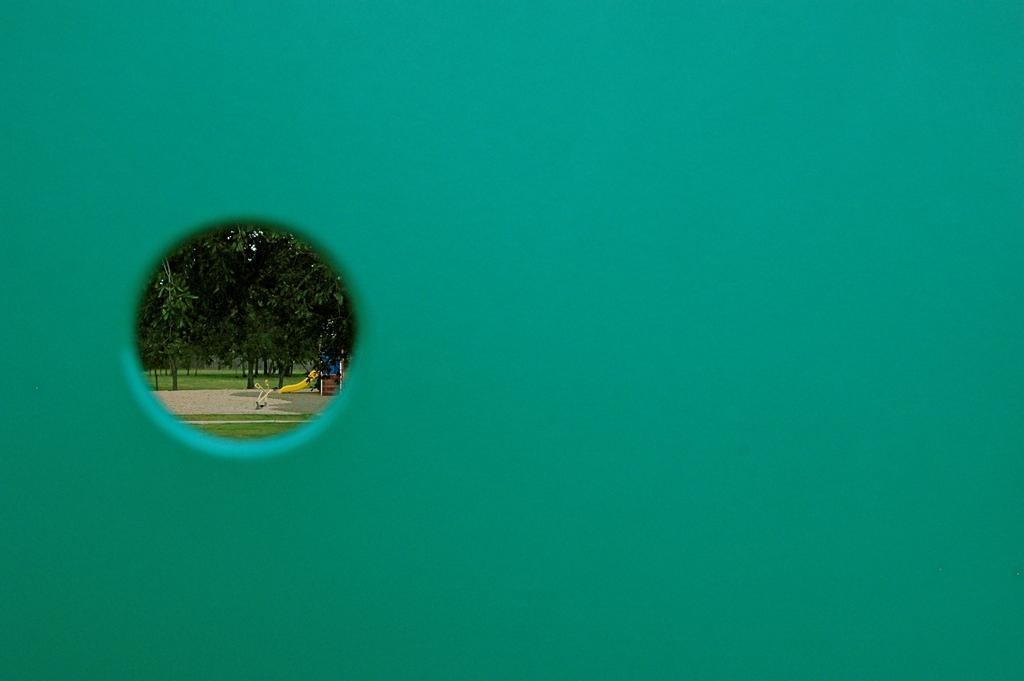Describe this image in one or two sentences. In the picture there is a wall, on the wall there is a hole, through the hole we can see trees, there is a path, there is a playing item present. 